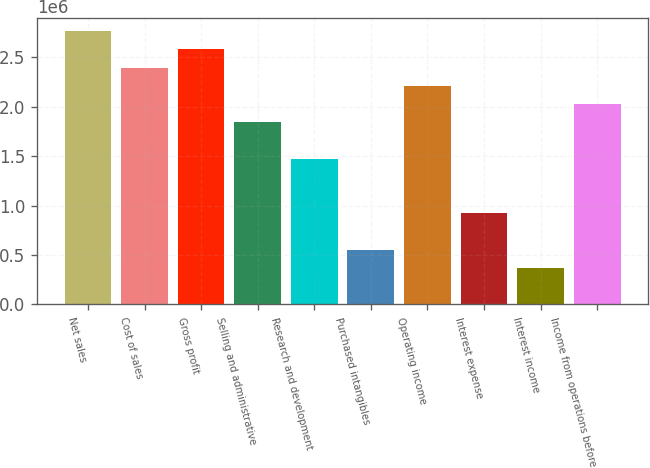Convert chart to OTSL. <chart><loc_0><loc_0><loc_500><loc_500><bar_chart><fcel>Net sales<fcel>Cost of sales<fcel>Gross profit<fcel>Selling and administrative<fcel>Research and development<fcel>Purchased intangibles<fcel>Operating income<fcel>Interest expense<fcel>Interest income<fcel>Income from operations before<nl><fcel>2.76546e+06<fcel>2.39673e+06<fcel>2.5811e+06<fcel>1.84364e+06<fcel>1.47491e+06<fcel>553096<fcel>2.21237e+06<fcel>921823<fcel>368732<fcel>2.028e+06<nl></chart> 